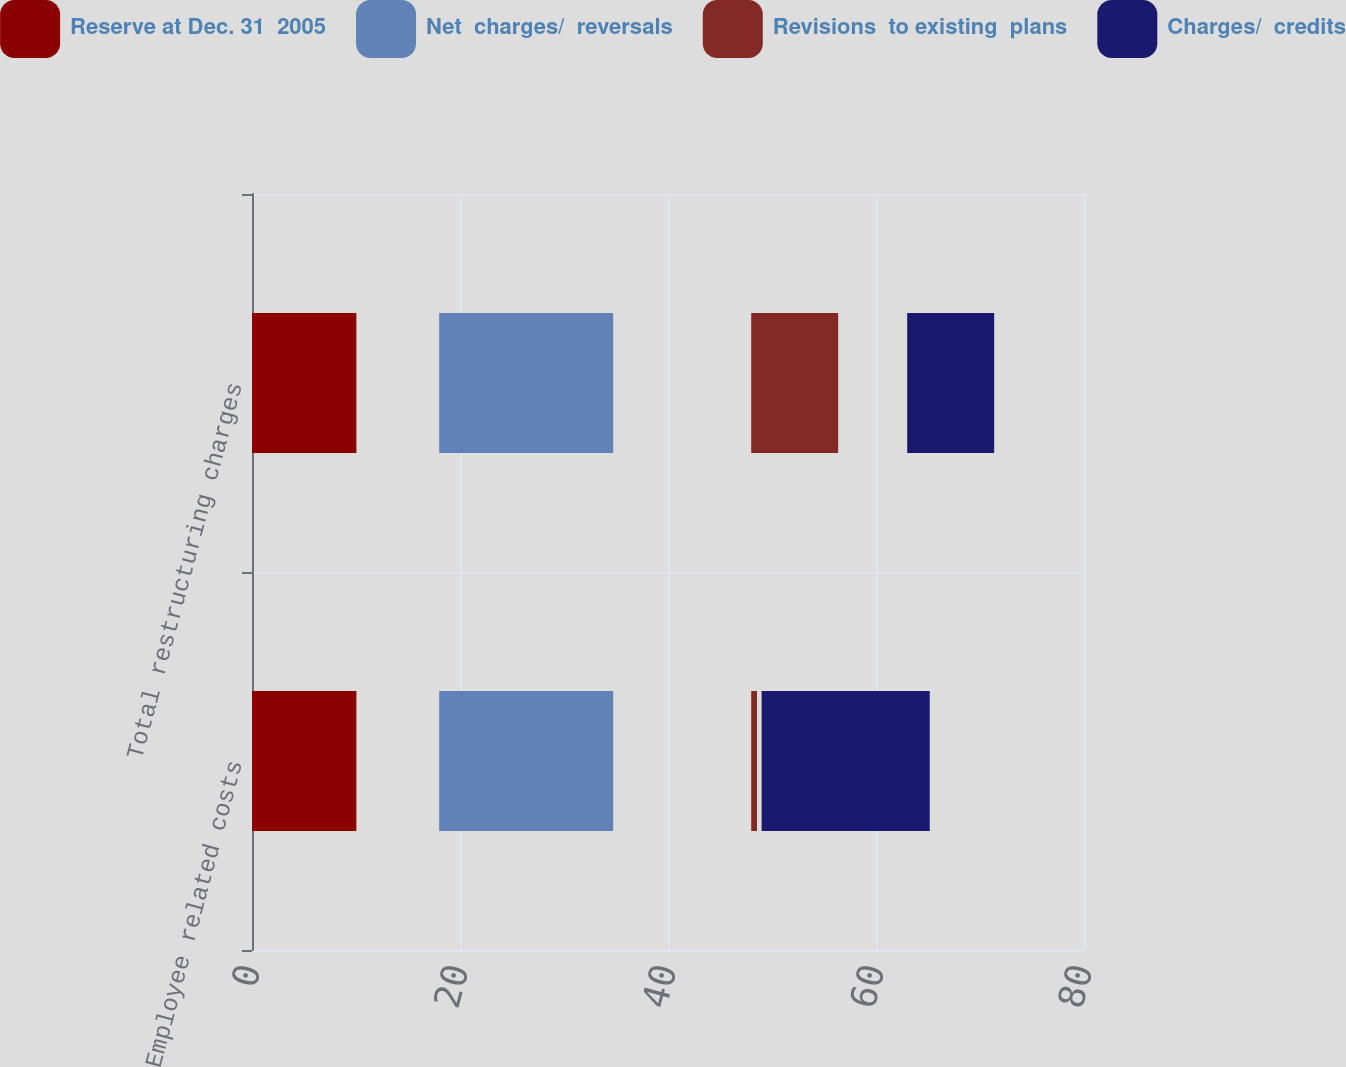Convert chart to OTSL. <chart><loc_0><loc_0><loc_500><loc_500><stacked_bar_chart><ecel><fcel>Employee related costs<fcel>Total restructuring charges<nl><fcel>Reserve at Dec. 31  2005<fcel>18<fcel>18<nl><fcel>Net  charges/  reversals<fcel>30<fcel>30<nl><fcel>Revisions  to existing  plans<fcel>1<fcel>15<nl><fcel>Charges/  credits<fcel>29<fcel>15<nl></chart> 